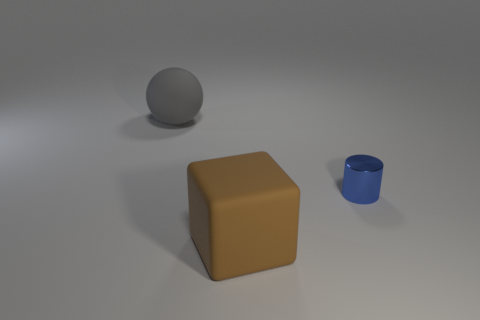There is a big thing that is right of the rubber object that is behind the brown matte object; are there any things that are behind it?
Make the answer very short. Yes. How many other rubber objects are the same size as the gray rubber object?
Keep it short and to the point. 1. What material is the thing that is in front of the blue metallic cylinder that is right of the matte sphere made of?
Offer a very short reply. Rubber. What shape is the large thing on the right side of the large object that is behind the big thing that is in front of the blue object?
Your response must be concise. Cube. Does the object to the right of the brown cube have the same shape as the rubber object in front of the cylinder?
Ensure brevity in your answer.  No. How many other things are there of the same material as the gray object?
Ensure brevity in your answer.  1. What shape is the big object that is the same material as the large gray sphere?
Make the answer very short. Cube. Is the brown cube the same size as the gray sphere?
Your response must be concise. Yes. What is the size of the blue cylinder right of the big matte object behind the large brown rubber cube?
Your response must be concise. Small. What number of blocks are either blue things or big brown rubber things?
Offer a terse response. 1. 